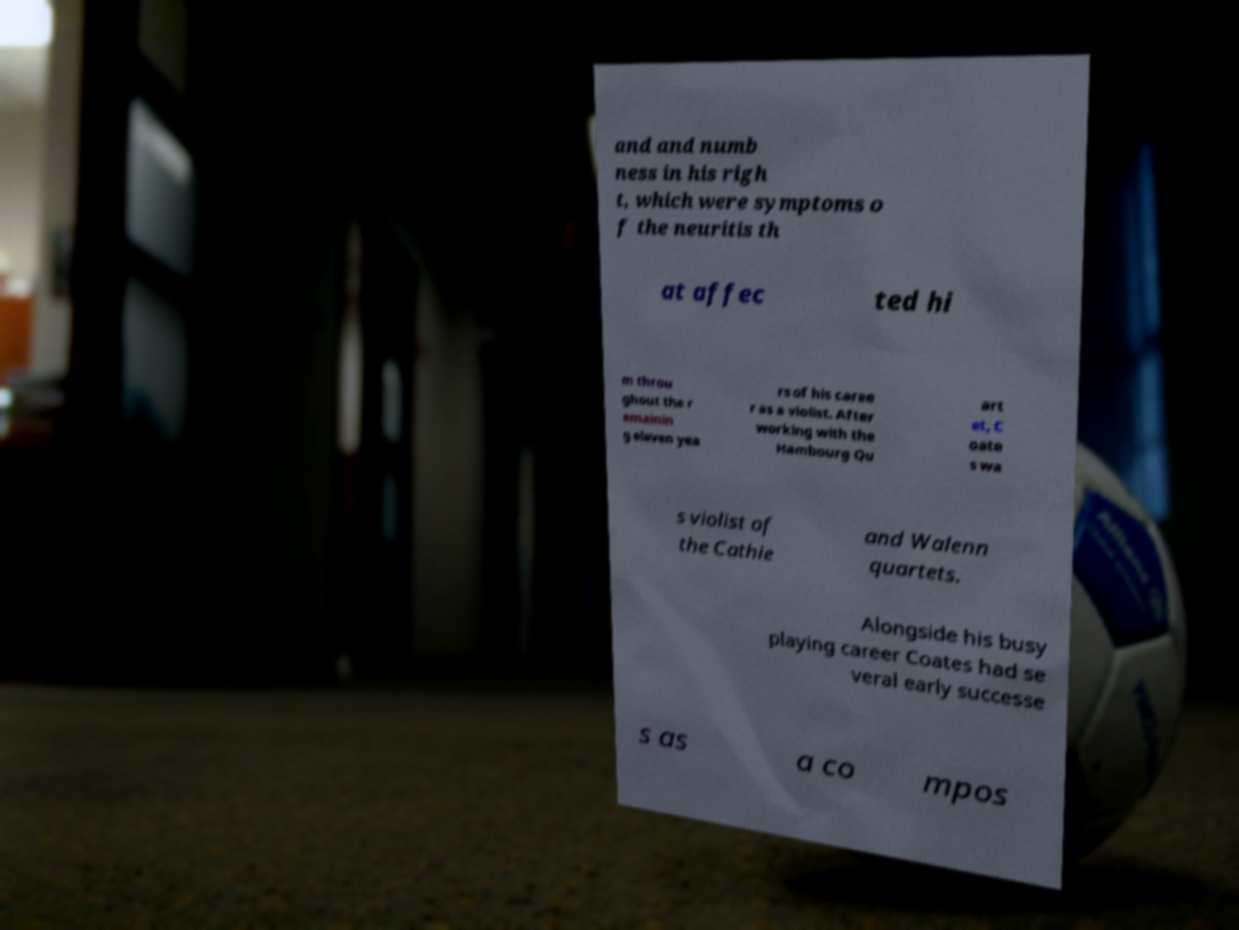I need the written content from this picture converted into text. Can you do that? and and numb ness in his righ t, which were symptoms o f the neuritis th at affec ted hi m throu ghout the r emainin g eleven yea rs of his caree r as a violist. After working with the Hambourg Qu art et, C oate s wa s violist of the Cathie and Walenn quartets. Alongside his busy playing career Coates had se veral early successe s as a co mpos 